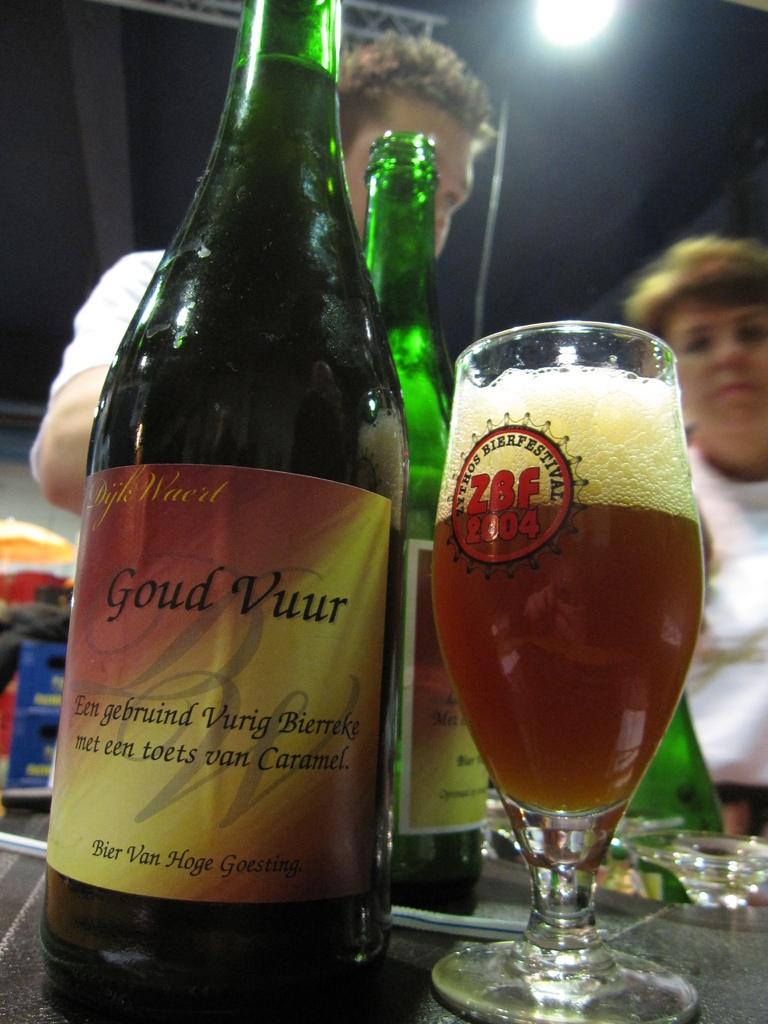What is in the bottle?
Make the answer very short. Goud vuur. What does the glass say?
Provide a short and direct response. Zythos bierfestival zbf 2004. 